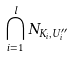<formula> <loc_0><loc_0><loc_500><loc_500>\bigcap _ { i = 1 } ^ { l } N _ { K _ { i } , U _ { i } ^ { \prime \prime } }</formula> 